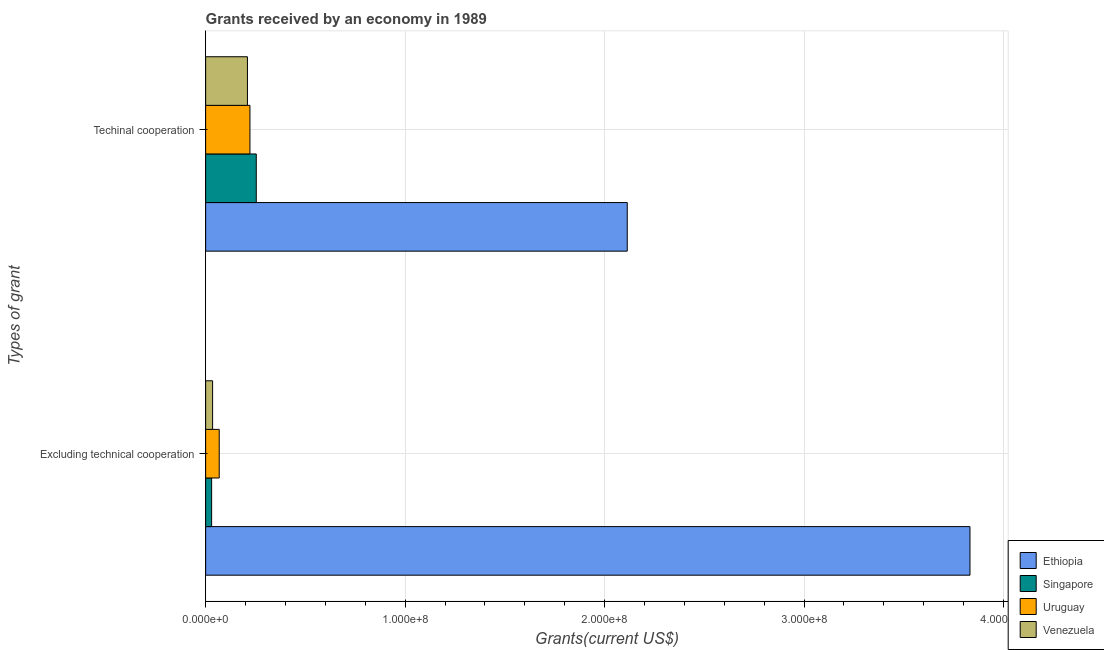What is the label of the 2nd group of bars from the top?
Keep it short and to the point. Excluding technical cooperation. What is the amount of grants received(excluding technical cooperation) in Ethiopia?
Your response must be concise. 3.83e+08. Across all countries, what is the maximum amount of grants received(including technical cooperation)?
Offer a very short reply. 2.11e+08. Across all countries, what is the minimum amount of grants received(including technical cooperation)?
Your response must be concise. 2.10e+07. In which country was the amount of grants received(excluding technical cooperation) maximum?
Offer a very short reply. Ethiopia. In which country was the amount of grants received(including technical cooperation) minimum?
Offer a terse response. Venezuela. What is the total amount of grants received(excluding technical cooperation) in the graph?
Provide a short and direct response. 3.96e+08. What is the difference between the amount of grants received(including technical cooperation) in Uruguay and that in Ethiopia?
Ensure brevity in your answer.  -1.89e+08. What is the difference between the amount of grants received(including technical cooperation) in Singapore and the amount of grants received(excluding technical cooperation) in Venezuela?
Keep it short and to the point. 2.19e+07. What is the average amount of grants received(including technical cooperation) per country?
Offer a terse response. 7.00e+07. What is the difference between the amount of grants received(excluding technical cooperation) and amount of grants received(including technical cooperation) in Singapore?
Keep it short and to the point. -2.24e+07. What is the ratio of the amount of grants received(including technical cooperation) in Venezuela to that in Ethiopia?
Your response must be concise. 0.1. In how many countries, is the amount of grants received(including technical cooperation) greater than the average amount of grants received(including technical cooperation) taken over all countries?
Your response must be concise. 1. What does the 3rd bar from the top in Excluding technical cooperation represents?
Your response must be concise. Singapore. What does the 3rd bar from the bottom in Techinal cooperation represents?
Make the answer very short. Uruguay. How many bars are there?
Offer a very short reply. 8. Are all the bars in the graph horizontal?
Offer a very short reply. Yes. Are the values on the major ticks of X-axis written in scientific E-notation?
Provide a short and direct response. Yes. Does the graph contain grids?
Your answer should be compact. Yes. How many legend labels are there?
Offer a terse response. 4. How are the legend labels stacked?
Your answer should be compact. Vertical. What is the title of the graph?
Provide a succinct answer. Grants received by an economy in 1989. Does "Morocco" appear as one of the legend labels in the graph?
Give a very brief answer. No. What is the label or title of the X-axis?
Provide a short and direct response. Grants(current US$). What is the label or title of the Y-axis?
Give a very brief answer. Types of grant. What is the Grants(current US$) of Ethiopia in Excluding technical cooperation?
Provide a succinct answer. 3.83e+08. What is the Grants(current US$) of Uruguay in Excluding technical cooperation?
Offer a very short reply. 6.81e+06. What is the Grants(current US$) of Venezuela in Excluding technical cooperation?
Keep it short and to the point. 3.50e+06. What is the Grants(current US$) in Ethiopia in Techinal cooperation?
Offer a terse response. 2.11e+08. What is the Grants(current US$) of Singapore in Techinal cooperation?
Provide a succinct answer. 2.54e+07. What is the Grants(current US$) of Uruguay in Techinal cooperation?
Provide a short and direct response. 2.22e+07. What is the Grants(current US$) in Venezuela in Techinal cooperation?
Your answer should be very brief. 2.10e+07. Across all Types of grant, what is the maximum Grants(current US$) in Ethiopia?
Provide a short and direct response. 3.83e+08. Across all Types of grant, what is the maximum Grants(current US$) of Singapore?
Your answer should be compact. 2.54e+07. Across all Types of grant, what is the maximum Grants(current US$) of Uruguay?
Keep it short and to the point. 2.22e+07. Across all Types of grant, what is the maximum Grants(current US$) in Venezuela?
Give a very brief answer. 2.10e+07. Across all Types of grant, what is the minimum Grants(current US$) of Ethiopia?
Offer a terse response. 2.11e+08. Across all Types of grant, what is the minimum Grants(current US$) of Uruguay?
Offer a terse response. 6.81e+06. Across all Types of grant, what is the minimum Grants(current US$) of Venezuela?
Provide a succinct answer. 3.50e+06. What is the total Grants(current US$) in Ethiopia in the graph?
Offer a very short reply. 5.95e+08. What is the total Grants(current US$) in Singapore in the graph?
Make the answer very short. 2.84e+07. What is the total Grants(current US$) in Uruguay in the graph?
Ensure brevity in your answer.  2.90e+07. What is the total Grants(current US$) of Venezuela in the graph?
Your answer should be compact. 2.45e+07. What is the difference between the Grants(current US$) in Ethiopia in Excluding technical cooperation and that in Techinal cooperation?
Keep it short and to the point. 1.72e+08. What is the difference between the Grants(current US$) of Singapore in Excluding technical cooperation and that in Techinal cooperation?
Make the answer very short. -2.24e+07. What is the difference between the Grants(current US$) in Uruguay in Excluding technical cooperation and that in Techinal cooperation?
Your response must be concise. -1.54e+07. What is the difference between the Grants(current US$) in Venezuela in Excluding technical cooperation and that in Techinal cooperation?
Ensure brevity in your answer.  -1.75e+07. What is the difference between the Grants(current US$) of Ethiopia in Excluding technical cooperation and the Grants(current US$) of Singapore in Techinal cooperation?
Your response must be concise. 3.58e+08. What is the difference between the Grants(current US$) in Ethiopia in Excluding technical cooperation and the Grants(current US$) in Uruguay in Techinal cooperation?
Make the answer very short. 3.61e+08. What is the difference between the Grants(current US$) in Ethiopia in Excluding technical cooperation and the Grants(current US$) in Venezuela in Techinal cooperation?
Ensure brevity in your answer.  3.62e+08. What is the difference between the Grants(current US$) of Singapore in Excluding technical cooperation and the Grants(current US$) of Uruguay in Techinal cooperation?
Your response must be concise. -1.92e+07. What is the difference between the Grants(current US$) in Singapore in Excluding technical cooperation and the Grants(current US$) in Venezuela in Techinal cooperation?
Ensure brevity in your answer.  -1.80e+07. What is the difference between the Grants(current US$) of Uruguay in Excluding technical cooperation and the Grants(current US$) of Venezuela in Techinal cooperation?
Make the answer very short. -1.42e+07. What is the average Grants(current US$) in Ethiopia per Types of grant?
Keep it short and to the point. 2.97e+08. What is the average Grants(current US$) in Singapore per Types of grant?
Give a very brief answer. 1.42e+07. What is the average Grants(current US$) of Uruguay per Types of grant?
Keep it short and to the point. 1.45e+07. What is the average Grants(current US$) of Venezuela per Types of grant?
Provide a succinct answer. 1.22e+07. What is the difference between the Grants(current US$) in Ethiopia and Grants(current US$) in Singapore in Excluding technical cooperation?
Your answer should be compact. 3.80e+08. What is the difference between the Grants(current US$) of Ethiopia and Grants(current US$) of Uruguay in Excluding technical cooperation?
Keep it short and to the point. 3.76e+08. What is the difference between the Grants(current US$) in Ethiopia and Grants(current US$) in Venezuela in Excluding technical cooperation?
Give a very brief answer. 3.80e+08. What is the difference between the Grants(current US$) of Singapore and Grants(current US$) of Uruguay in Excluding technical cooperation?
Make the answer very short. -3.81e+06. What is the difference between the Grants(current US$) of Singapore and Grants(current US$) of Venezuela in Excluding technical cooperation?
Provide a short and direct response. -5.00e+05. What is the difference between the Grants(current US$) of Uruguay and Grants(current US$) of Venezuela in Excluding technical cooperation?
Your response must be concise. 3.31e+06. What is the difference between the Grants(current US$) in Ethiopia and Grants(current US$) in Singapore in Techinal cooperation?
Keep it short and to the point. 1.86e+08. What is the difference between the Grants(current US$) of Ethiopia and Grants(current US$) of Uruguay in Techinal cooperation?
Ensure brevity in your answer.  1.89e+08. What is the difference between the Grants(current US$) of Ethiopia and Grants(current US$) of Venezuela in Techinal cooperation?
Make the answer very short. 1.90e+08. What is the difference between the Grants(current US$) of Singapore and Grants(current US$) of Uruguay in Techinal cooperation?
Keep it short and to the point. 3.17e+06. What is the difference between the Grants(current US$) in Singapore and Grants(current US$) in Venezuela in Techinal cooperation?
Your answer should be compact. 4.42e+06. What is the difference between the Grants(current US$) in Uruguay and Grants(current US$) in Venezuela in Techinal cooperation?
Offer a very short reply. 1.25e+06. What is the ratio of the Grants(current US$) in Ethiopia in Excluding technical cooperation to that in Techinal cooperation?
Your answer should be very brief. 1.81. What is the ratio of the Grants(current US$) of Singapore in Excluding technical cooperation to that in Techinal cooperation?
Your answer should be very brief. 0.12. What is the ratio of the Grants(current US$) of Uruguay in Excluding technical cooperation to that in Techinal cooperation?
Provide a succinct answer. 0.31. What is the ratio of the Grants(current US$) in Venezuela in Excluding technical cooperation to that in Techinal cooperation?
Give a very brief answer. 0.17. What is the difference between the highest and the second highest Grants(current US$) in Ethiopia?
Provide a short and direct response. 1.72e+08. What is the difference between the highest and the second highest Grants(current US$) of Singapore?
Offer a terse response. 2.24e+07. What is the difference between the highest and the second highest Grants(current US$) in Uruguay?
Provide a short and direct response. 1.54e+07. What is the difference between the highest and the second highest Grants(current US$) of Venezuela?
Provide a short and direct response. 1.75e+07. What is the difference between the highest and the lowest Grants(current US$) in Ethiopia?
Give a very brief answer. 1.72e+08. What is the difference between the highest and the lowest Grants(current US$) of Singapore?
Give a very brief answer. 2.24e+07. What is the difference between the highest and the lowest Grants(current US$) in Uruguay?
Your answer should be very brief. 1.54e+07. What is the difference between the highest and the lowest Grants(current US$) in Venezuela?
Make the answer very short. 1.75e+07. 